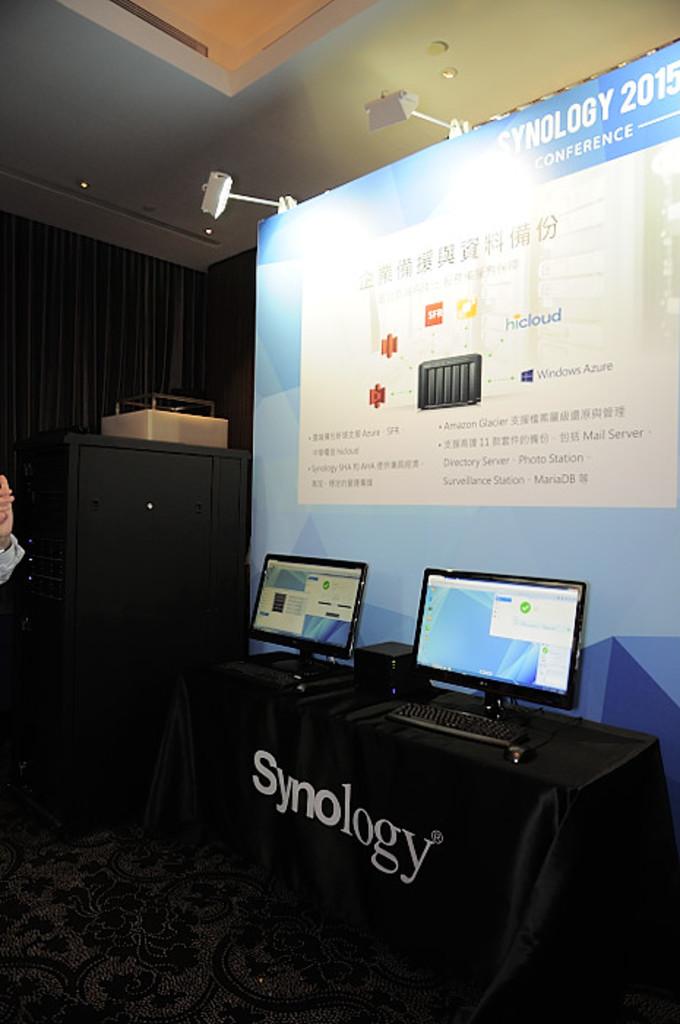What is this stand set up for?
Make the answer very short. Synology. What company's booth is this?
Provide a short and direct response. Synology. 